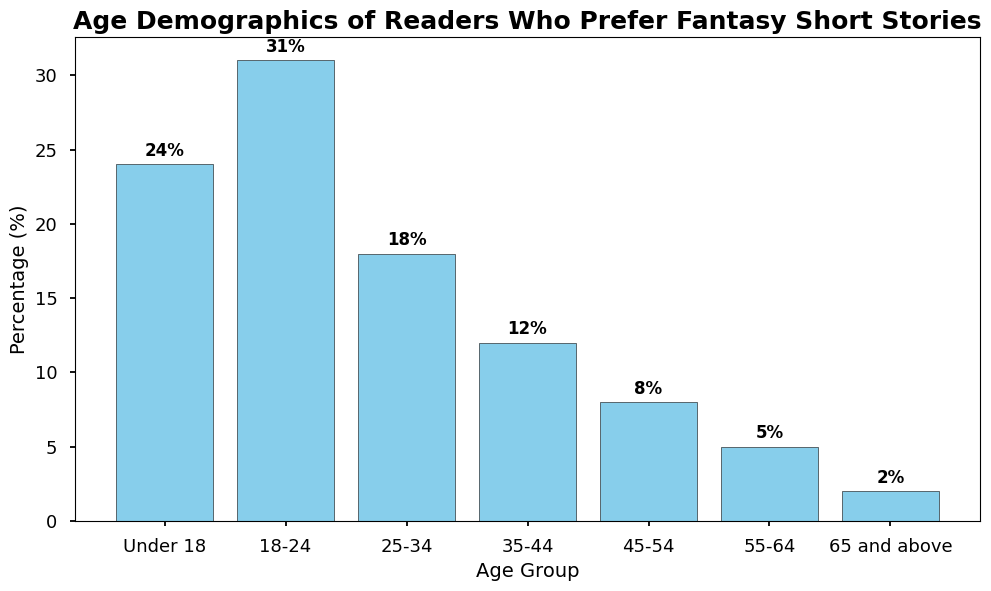Which age group prefers fantasy short stories the most? The highest bar indicates the age group 18-24, which has the highest percentage of readers at 31%.
Answer: 18-24 Which age group prefers fantasy short stories the least? The shortest bar represents the age group 65 and above with only 2% of readers.
Answer: 65 and above What is the combined percentage of readers who are below 25 years old? Add the percentages of "Under 18" (24%) and "18-24" (31%): 24% + 31% = 55%.
Answer: 55 Is the percentage of readers in the 25-34 age group greater than those in the 35-44 age group? The bar for the 25-34 age group (18%) is taller than the bar for the 35-44 age group (12%), indicating a higher percentage.
Answer: Yes What's the difference in percentage between the highest and lowest age groups? Subtract the lowest percentage (65 and above, 2%) from the highest percentage (18-24, 31%): 31% - 2% = 29%.
Answer: 29 Do readers aged 45 and above constitute more or less than 20% of the total readership? Add the percentages of readers from 45-54 (8%), 55-64 (5%), and 65 and above (2%): 8% + 5% + 2% = 15%, which is less than 20%.
Answer: Less How does the percentage of readers aged 18-24 compare with those aged 25-34? The percentage of readers aged 18-24 is 31%, whereas for the 25-34 age group, it is 18%. 31% is significantly higher than 18%.
Answer: Higher What's the cumulative percentage of readers in the age groups 35-44 and 55-64? Add the percentages for 35-44 (12%) and 55-64 (5%): 12% + 5% = 17%.
Answer: 17 Is the visual representation of the height of the bars consistent with the percentages? Yes, the heights of the bars accurately reflect their respective percentages, with taller bars indicating higher percentages.
Answer: Yes 